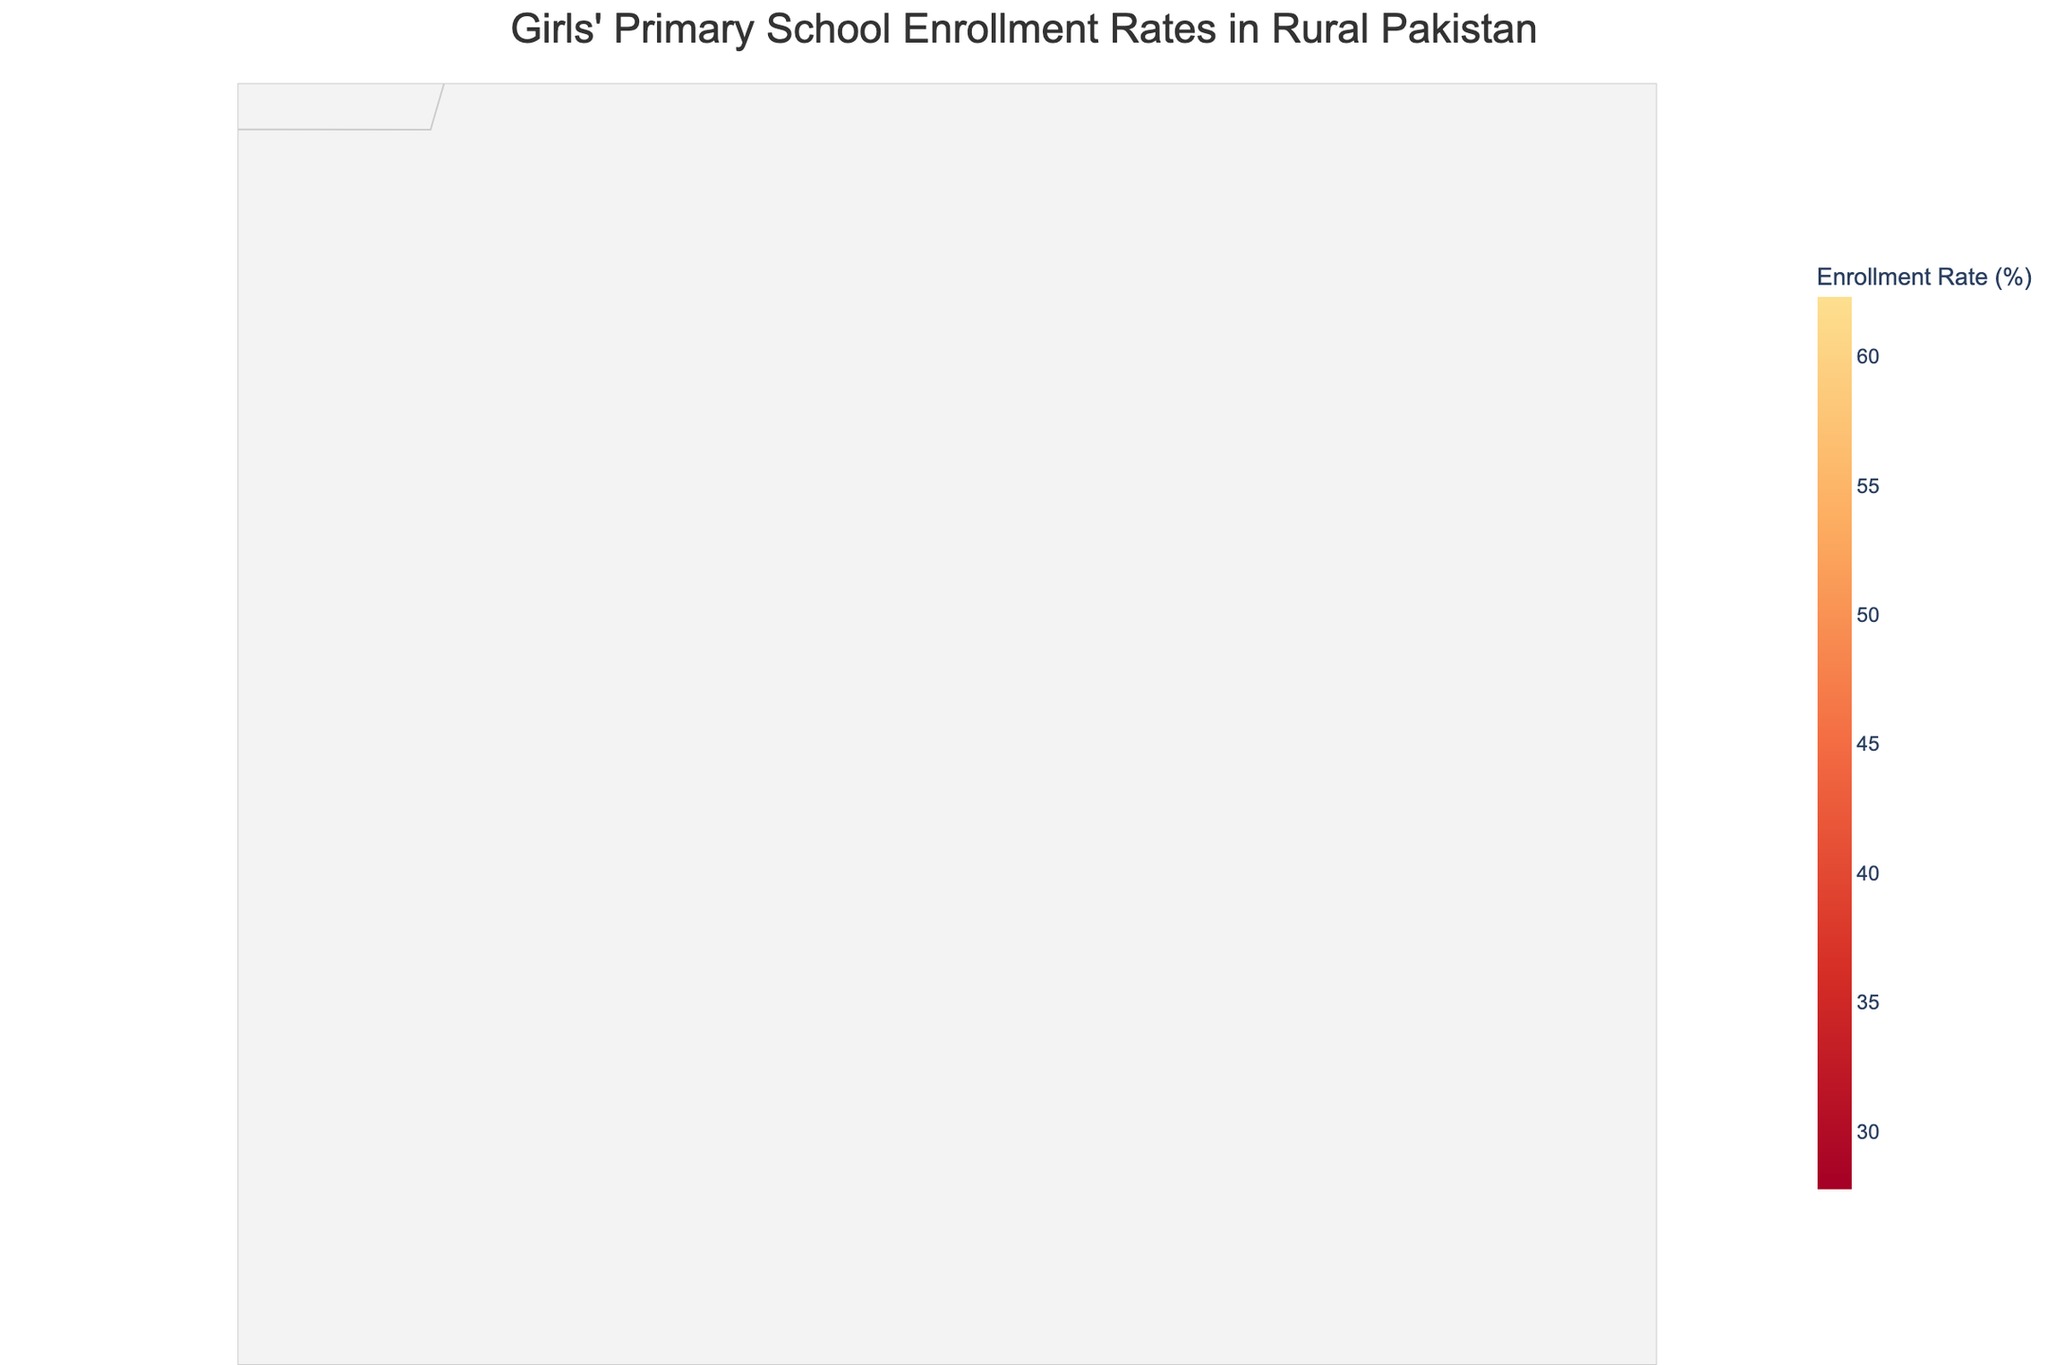What is the title of the figure? The title is typically displayed at the top of the figure. From the code, we know the title is "Girls' Primary School Enrollment Rates in Rural Pakistan".
Answer: Girls' Primary School Enrollment Rates in Rural Pakistan Which province has the highest female enrollment rate in primary schools? By visually inspecting the figure, locate the regions with the highest color intensity corresponding to high enrollment rates, and identify their respective provinces.
Answer: Punjab Which district in Sindh has the lowest girls' primary school enrollment rate? Identify the districts within Sindh, then compare the color intensities. The district with the lowest intensity has the lowest enrollment rate.
Answer: Tharparkar What is the range of girls' enrollment rates displayed on the color bar? Examine the color bar usually placed on the side or bottom of the figure to identify the minimum and maximum values it represents.
Answer: 27.8% to 62.3% Which district in Khyber Pakhtunkhwa has a higher enrollment rate: Kohistan or Battagram? Identify the color intensities associated with Kohistan and Battagram. The district with the higher intensity has the higher rate.
Answer: Battagram In what province is the district Musakhel located and what is its enrollment rate? From the hover data in the code, identify Musakhel, determine its province, and read its corresponding enrollment rate.
Answer: Balochistan, 27.8% Compare the average enrollment rate of districts in Punjab to that of Sindh. Calculate the average rate for districts in Punjab (Bhakkar, Mianwali, Rahim Yar Khan) and Sindh (Tharparkar, Umerkot, Sanghar), then compare the two averages.
Answer: Punjab: 58.7%, Sindh: 45.5% Considering Balochistan and Gilgit-Baltistan, which province has a higher overall enrollment rate? Calculate the average enrollment rates for all districts in Balochistan (Musakhel, Zhob, Killa Abdullah) and Gilgit-Baltistan (Diamer, Ghizer, Astore), then compare the averages.
Answer: Gilgit-Baltistan How does the enrollment rate in Rahim Yar Khan compare with that in Ghizer? Locate the corresponding color intensities for both Rahim Yar Khan and Ghizer on the figure and directly compare their values.
Answer: Rahim Yar Khan has a lower enrollment rate Which district has the middle enrollment rate if the districts were sorted by their rates? Sort each district by their enrollment rates and identify the one in the middle position.
Answer: Astore 